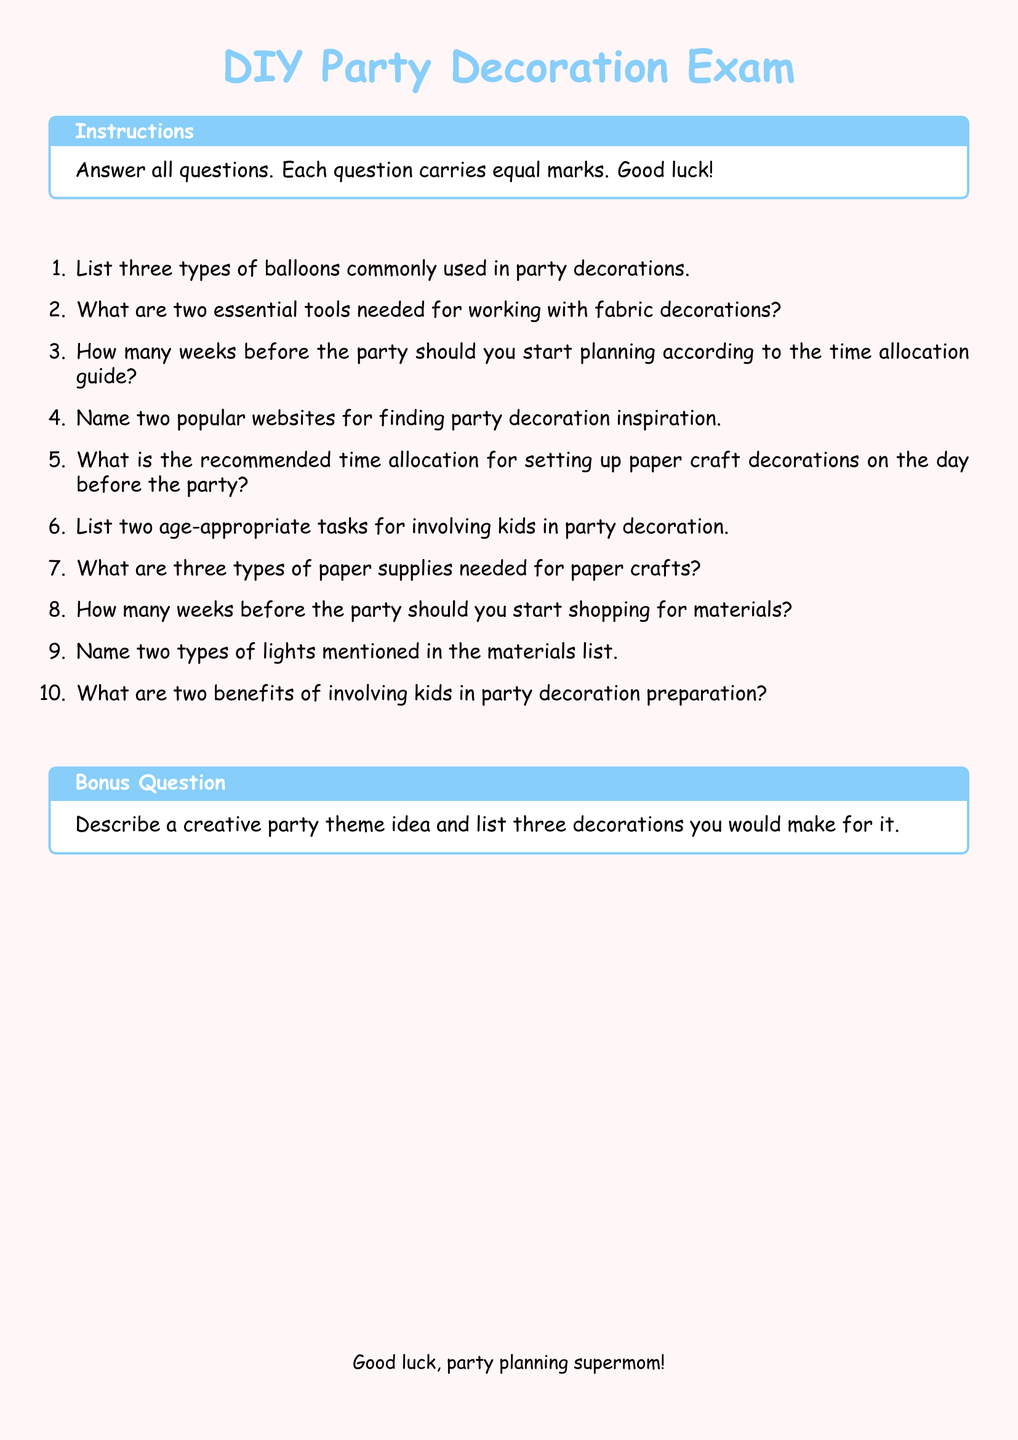What are three types of balloons commonly used in party decorations? The question seeks specific types of balloons mentioned in the document.
Answer: Three types of balloons What are two essential tools needed for working with fabric decorations? The question asks for specific tools outlined in the document.
Answer: Two essential tools How many weeks before the party should you start planning according to the time allocation guide? This question requires the exact number of weeks stated in the document.
Answer: Number of weeks What is the recommended time allocation for setting up paper craft decorations on the day before the party? The query focuses on time allocation information presented in the document.
Answer: Recommended time allocation List two age-appropriate tasks for involving kids in party decoration. This question looks for specific tasks that can engage children as outlined in the document.
Answer: Two age-appropriate tasks Name two types of lights mentioned in the materials list. The question seeks specific types of lights included in the materials section of the document.
Answer: Two types of lights What are two benefits of involving kids in party decoration preparation? The focus here is on the advantages mentioned in the document regarding kid participation.
Answer: Two benefits Describe a creative party theme idea and list three decorations you would make for it. This bonus question encourages creativity and application of learned skills from the document.
Answer: Creative party theme idea 